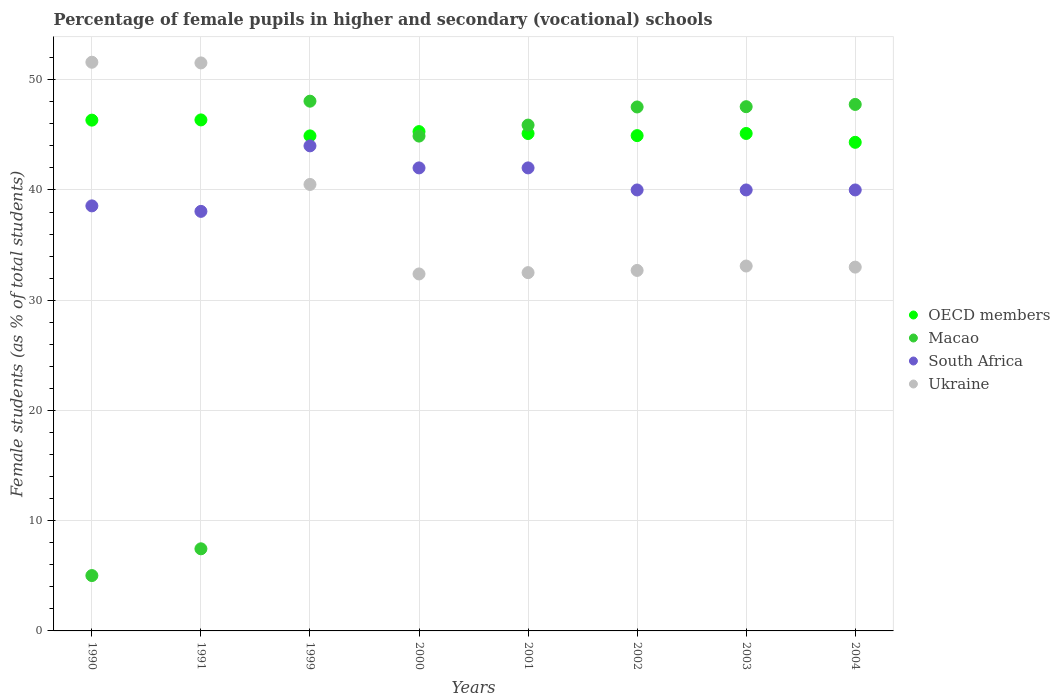How many different coloured dotlines are there?
Your answer should be very brief. 4. What is the percentage of female pupils in higher and secondary schools in Macao in 2003?
Your response must be concise. 47.55. Across all years, what is the maximum percentage of female pupils in higher and secondary schools in South Africa?
Offer a very short reply. 44. Across all years, what is the minimum percentage of female pupils in higher and secondary schools in OECD members?
Offer a very short reply. 44.32. What is the total percentage of female pupils in higher and secondary schools in Ukraine in the graph?
Provide a short and direct response. 307.29. What is the difference between the percentage of female pupils in higher and secondary schools in OECD members in 1999 and that in 2000?
Your answer should be compact. -0.39. What is the difference between the percentage of female pupils in higher and secondary schools in Macao in 2004 and the percentage of female pupils in higher and secondary schools in Ukraine in 2000?
Offer a terse response. 15.38. What is the average percentage of female pupils in higher and secondary schools in Ukraine per year?
Make the answer very short. 38.41. In the year 1991, what is the difference between the percentage of female pupils in higher and secondary schools in South Africa and percentage of female pupils in higher and secondary schools in OECD members?
Offer a terse response. -8.3. In how many years, is the percentage of female pupils in higher and secondary schools in Macao greater than 30 %?
Give a very brief answer. 6. What is the ratio of the percentage of female pupils in higher and secondary schools in South Africa in 1990 to that in 2003?
Ensure brevity in your answer.  0.96. Is the difference between the percentage of female pupils in higher and secondary schools in South Africa in 2002 and 2004 greater than the difference between the percentage of female pupils in higher and secondary schools in OECD members in 2002 and 2004?
Offer a terse response. No. What is the difference between the highest and the second highest percentage of female pupils in higher and secondary schools in OECD members?
Provide a short and direct response. 0.02. What is the difference between the highest and the lowest percentage of female pupils in higher and secondary schools in Macao?
Keep it short and to the point. 43.03. In how many years, is the percentage of female pupils in higher and secondary schools in Ukraine greater than the average percentage of female pupils in higher and secondary schools in Ukraine taken over all years?
Provide a short and direct response. 3. Is the sum of the percentage of female pupils in higher and secondary schools in South Africa in 1990 and 2000 greater than the maximum percentage of female pupils in higher and secondary schools in OECD members across all years?
Provide a succinct answer. Yes. Is it the case that in every year, the sum of the percentage of female pupils in higher and secondary schools in Macao and percentage of female pupils in higher and secondary schools in Ukraine  is greater than the percentage of female pupils in higher and secondary schools in OECD members?
Ensure brevity in your answer.  Yes. Does the percentage of female pupils in higher and secondary schools in South Africa monotonically increase over the years?
Offer a terse response. No. What is the difference between two consecutive major ticks on the Y-axis?
Offer a very short reply. 10. Are the values on the major ticks of Y-axis written in scientific E-notation?
Your response must be concise. No. What is the title of the graph?
Your response must be concise. Percentage of female pupils in higher and secondary (vocational) schools. Does "Poland" appear as one of the legend labels in the graph?
Ensure brevity in your answer.  No. What is the label or title of the X-axis?
Offer a very short reply. Years. What is the label or title of the Y-axis?
Keep it short and to the point. Female students (as % of total students). What is the Female students (as % of total students) in OECD members in 1990?
Provide a succinct answer. 46.33. What is the Female students (as % of total students) in Macao in 1990?
Provide a short and direct response. 5.02. What is the Female students (as % of total students) in South Africa in 1990?
Your answer should be compact. 38.56. What is the Female students (as % of total students) of Ukraine in 1990?
Your response must be concise. 51.58. What is the Female students (as % of total students) in OECD members in 1991?
Keep it short and to the point. 46.35. What is the Female students (as % of total students) of Macao in 1991?
Offer a terse response. 7.45. What is the Female students (as % of total students) in South Africa in 1991?
Offer a very short reply. 38.06. What is the Female students (as % of total students) in Ukraine in 1991?
Your response must be concise. 51.52. What is the Female students (as % of total students) in OECD members in 1999?
Provide a short and direct response. 44.9. What is the Female students (as % of total students) of Macao in 1999?
Provide a succinct answer. 48.05. What is the Female students (as % of total students) in South Africa in 1999?
Your answer should be very brief. 44. What is the Female students (as % of total students) of Ukraine in 1999?
Keep it short and to the point. 40.5. What is the Female students (as % of total students) of OECD members in 2000?
Your answer should be compact. 45.29. What is the Female students (as % of total students) in Macao in 2000?
Your answer should be compact. 44.89. What is the Female students (as % of total students) in South Africa in 2000?
Offer a terse response. 42. What is the Female students (as % of total students) in Ukraine in 2000?
Offer a very short reply. 32.38. What is the Female students (as % of total students) of OECD members in 2001?
Your answer should be very brief. 45.12. What is the Female students (as % of total students) in Macao in 2001?
Make the answer very short. 45.88. What is the Female students (as % of total students) in South Africa in 2001?
Give a very brief answer. 42. What is the Female students (as % of total students) in Ukraine in 2001?
Your answer should be very brief. 32.5. What is the Female students (as % of total students) of OECD members in 2002?
Your response must be concise. 44.93. What is the Female students (as % of total students) of Macao in 2002?
Your answer should be very brief. 47.53. What is the Female students (as % of total students) of South Africa in 2002?
Keep it short and to the point. 40. What is the Female students (as % of total students) of Ukraine in 2002?
Your response must be concise. 32.7. What is the Female students (as % of total students) of OECD members in 2003?
Offer a very short reply. 45.12. What is the Female students (as % of total students) in Macao in 2003?
Provide a short and direct response. 47.55. What is the Female students (as % of total students) in South Africa in 2003?
Offer a terse response. 40. What is the Female students (as % of total students) in Ukraine in 2003?
Make the answer very short. 33.1. What is the Female students (as % of total students) in OECD members in 2004?
Your answer should be very brief. 44.32. What is the Female students (as % of total students) in Macao in 2004?
Make the answer very short. 47.76. What is the Female students (as % of total students) in South Africa in 2004?
Your answer should be very brief. 40. What is the Female students (as % of total students) in Ukraine in 2004?
Keep it short and to the point. 33. Across all years, what is the maximum Female students (as % of total students) of OECD members?
Provide a succinct answer. 46.35. Across all years, what is the maximum Female students (as % of total students) in Macao?
Your answer should be compact. 48.05. Across all years, what is the maximum Female students (as % of total students) in South Africa?
Your answer should be very brief. 44. Across all years, what is the maximum Female students (as % of total students) of Ukraine?
Offer a very short reply. 51.58. Across all years, what is the minimum Female students (as % of total students) in OECD members?
Offer a terse response. 44.32. Across all years, what is the minimum Female students (as % of total students) of Macao?
Provide a succinct answer. 5.02. Across all years, what is the minimum Female students (as % of total students) in South Africa?
Your answer should be compact. 38.06. Across all years, what is the minimum Female students (as % of total students) in Ukraine?
Make the answer very short. 32.38. What is the total Female students (as % of total students) of OECD members in the graph?
Ensure brevity in your answer.  362.38. What is the total Female students (as % of total students) of Macao in the graph?
Offer a very short reply. 294.13. What is the total Female students (as % of total students) of South Africa in the graph?
Your answer should be compact. 324.61. What is the total Female students (as % of total students) in Ukraine in the graph?
Your answer should be very brief. 307.29. What is the difference between the Female students (as % of total students) in OECD members in 1990 and that in 1991?
Provide a succinct answer. -0.02. What is the difference between the Female students (as % of total students) in Macao in 1990 and that in 1991?
Give a very brief answer. -2.43. What is the difference between the Female students (as % of total students) of South Africa in 1990 and that in 1991?
Ensure brevity in your answer.  0.5. What is the difference between the Female students (as % of total students) in Ukraine in 1990 and that in 1991?
Offer a terse response. 0.06. What is the difference between the Female students (as % of total students) of OECD members in 1990 and that in 1999?
Offer a terse response. 1.43. What is the difference between the Female students (as % of total students) of Macao in 1990 and that in 1999?
Keep it short and to the point. -43.03. What is the difference between the Female students (as % of total students) in South Africa in 1990 and that in 1999?
Keep it short and to the point. -5.44. What is the difference between the Female students (as % of total students) in Ukraine in 1990 and that in 1999?
Make the answer very short. 11.08. What is the difference between the Female students (as % of total students) in OECD members in 1990 and that in 2000?
Ensure brevity in your answer.  1.04. What is the difference between the Female students (as % of total students) of Macao in 1990 and that in 2000?
Your answer should be compact. -39.86. What is the difference between the Female students (as % of total students) of South Africa in 1990 and that in 2000?
Give a very brief answer. -3.44. What is the difference between the Female students (as % of total students) of Ukraine in 1990 and that in 2000?
Your answer should be very brief. 19.2. What is the difference between the Female students (as % of total students) in OECD members in 1990 and that in 2001?
Provide a short and direct response. 1.21. What is the difference between the Female students (as % of total students) in Macao in 1990 and that in 2001?
Your answer should be compact. -40.86. What is the difference between the Female students (as % of total students) of South Africa in 1990 and that in 2001?
Keep it short and to the point. -3.44. What is the difference between the Female students (as % of total students) in Ukraine in 1990 and that in 2001?
Offer a terse response. 19.09. What is the difference between the Female students (as % of total students) in OECD members in 1990 and that in 2002?
Give a very brief answer. 1.4. What is the difference between the Female students (as % of total students) in Macao in 1990 and that in 2002?
Offer a terse response. -42.51. What is the difference between the Female students (as % of total students) of South Africa in 1990 and that in 2002?
Your answer should be compact. -1.44. What is the difference between the Female students (as % of total students) of Ukraine in 1990 and that in 2002?
Your answer should be very brief. 18.88. What is the difference between the Female students (as % of total students) of OECD members in 1990 and that in 2003?
Your answer should be compact. 1.21. What is the difference between the Female students (as % of total students) of Macao in 1990 and that in 2003?
Make the answer very short. -42.53. What is the difference between the Female students (as % of total students) in South Africa in 1990 and that in 2003?
Your response must be concise. -1.44. What is the difference between the Female students (as % of total students) of Ukraine in 1990 and that in 2003?
Make the answer very short. 18.48. What is the difference between the Female students (as % of total students) in OECD members in 1990 and that in 2004?
Your answer should be very brief. 2.01. What is the difference between the Female students (as % of total students) of Macao in 1990 and that in 2004?
Your response must be concise. -42.74. What is the difference between the Female students (as % of total students) in South Africa in 1990 and that in 2004?
Offer a very short reply. -1.44. What is the difference between the Female students (as % of total students) of Ukraine in 1990 and that in 2004?
Offer a very short reply. 18.58. What is the difference between the Female students (as % of total students) of OECD members in 1991 and that in 1999?
Offer a terse response. 1.45. What is the difference between the Female students (as % of total students) in Macao in 1991 and that in 1999?
Keep it short and to the point. -40.6. What is the difference between the Female students (as % of total students) of South Africa in 1991 and that in 1999?
Offer a very short reply. -5.94. What is the difference between the Female students (as % of total students) of Ukraine in 1991 and that in 1999?
Your answer should be compact. 11.02. What is the difference between the Female students (as % of total students) of OECD members in 1991 and that in 2000?
Provide a short and direct response. 1.06. What is the difference between the Female students (as % of total students) in Macao in 1991 and that in 2000?
Your answer should be compact. -37.44. What is the difference between the Female students (as % of total students) in South Africa in 1991 and that in 2000?
Provide a short and direct response. -3.94. What is the difference between the Female students (as % of total students) in Ukraine in 1991 and that in 2000?
Your answer should be compact. 19.14. What is the difference between the Female students (as % of total students) in OECD members in 1991 and that in 2001?
Offer a terse response. 1.23. What is the difference between the Female students (as % of total students) of Macao in 1991 and that in 2001?
Keep it short and to the point. -38.44. What is the difference between the Female students (as % of total students) in South Africa in 1991 and that in 2001?
Ensure brevity in your answer.  -3.94. What is the difference between the Female students (as % of total students) of Ukraine in 1991 and that in 2001?
Give a very brief answer. 19.02. What is the difference between the Female students (as % of total students) of OECD members in 1991 and that in 2002?
Your answer should be very brief. 1.43. What is the difference between the Female students (as % of total students) of Macao in 1991 and that in 2002?
Provide a short and direct response. -40.08. What is the difference between the Female students (as % of total students) of South Africa in 1991 and that in 2002?
Offer a very short reply. -1.94. What is the difference between the Female students (as % of total students) of Ukraine in 1991 and that in 2002?
Your response must be concise. 18.82. What is the difference between the Female students (as % of total students) of OECD members in 1991 and that in 2003?
Your answer should be compact. 1.23. What is the difference between the Female students (as % of total students) in Macao in 1991 and that in 2003?
Your answer should be very brief. -40.1. What is the difference between the Female students (as % of total students) in South Africa in 1991 and that in 2003?
Offer a very short reply. -1.94. What is the difference between the Female students (as % of total students) in Ukraine in 1991 and that in 2003?
Provide a short and direct response. 18.42. What is the difference between the Female students (as % of total students) of OECD members in 1991 and that in 2004?
Make the answer very short. 2.03. What is the difference between the Female students (as % of total students) of Macao in 1991 and that in 2004?
Give a very brief answer. -40.31. What is the difference between the Female students (as % of total students) in South Africa in 1991 and that in 2004?
Ensure brevity in your answer.  -1.94. What is the difference between the Female students (as % of total students) of Ukraine in 1991 and that in 2004?
Keep it short and to the point. 18.52. What is the difference between the Female students (as % of total students) of OECD members in 1999 and that in 2000?
Offer a very short reply. -0.39. What is the difference between the Female students (as % of total students) in Macao in 1999 and that in 2000?
Your answer should be very brief. 3.17. What is the difference between the Female students (as % of total students) in South Africa in 1999 and that in 2000?
Your answer should be very brief. 2. What is the difference between the Female students (as % of total students) in Ukraine in 1999 and that in 2000?
Your response must be concise. 8.12. What is the difference between the Female students (as % of total students) in OECD members in 1999 and that in 2001?
Offer a very short reply. -0.22. What is the difference between the Female students (as % of total students) in Macao in 1999 and that in 2001?
Give a very brief answer. 2.17. What is the difference between the Female students (as % of total students) of South Africa in 1999 and that in 2001?
Your answer should be compact. 2. What is the difference between the Female students (as % of total students) in Ukraine in 1999 and that in 2001?
Your answer should be compact. 8. What is the difference between the Female students (as % of total students) of OECD members in 1999 and that in 2002?
Make the answer very short. -0.03. What is the difference between the Female students (as % of total students) in Macao in 1999 and that in 2002?
Keep it short and to the point. 0.53. What is the difference between the Female students (as % of total students) in South Africa in 1999 and that in 2002?
Provide a short and direct response. 4. What is the difference between the Female students (as % of total students) of Ukraine in 1999 and that in 2002?
Keep it short and to the point. 7.8. What is the difference between the Female students (as % of total students) of OECD members in 1999 and that in 2003?
Your answer should be very brief. -0.22. What is the difference between the Female students (as % of total students) of Macao in 1999 and that in 2003?
Provide a short and direct response. 0.5. What is the difference between the Female students (as % of total students) of South Africa in 1999 and that in 2003?
Your answer should be very brief. 4. What is the difference between the Female students (as % of total students) of Ukraine in 1999 and that in 2003?
Offer a very short reply. 7.4. What is the difference between the Female students (as % of total students) of OECD members in 1999 and that in 2004?
Your answer should be compact. 0.58. What is the difference between the Female students (as % of total students) of Macao in 1999 and that in 2004?
Give a very brief answer. 0.3. What is the difference between the Female students (as % of total students) of South Africa in 1999 and that in 2004?
Offer a terse response. 4. What is the difference between the Female students (as % of total students) in Ukraine in 1999 and that in 2004?
Provide a short and direct response. 7.5. What is the difference between the Female students (as % of total students) in OECD members in 2000 and that in 2001?
Provide a succinct answer. 0.17. What is the difference between the Female students (as % of total students) of Macao in 2000 and that in 2001?
Your response must be concise. -1. What is the difference between the Female students (as % of total students) of South Africa in 2000 and that in 2001?
Give a very brief answer. 0. What is the difference between the Female students (as % of total students) in Ukraine in 2000 and that in 2001?
Your answer should be compact. -0.12. What is the difference between the Female students (as % of total students) of OECD members in 2000 and that in 2002?
Keep it short and to the point. 0.36. What is the difference between the Female students (as % of total students) in Macao in 2000 and that in 2002?
Keep it short and to the point. -2.64. What is the difference between the Female students (as % of total students) in South Africa in 2000 and that in 2002?
Give a very brief answer. 2. What is the difference between the Female students (as % of total students) of Ukraine in 2000 and that in 2002?
Provide a succinct answer. -0.32. What is the difference between the Female students (as % of total students) of OECD members in 2000 and that in 2003?
Your answer should be compact. 0.17. What is the difference between the Female students (as % of total students) of Macao in 2000 and that in 2003?
Provide a short and direct response. -2.67. What is the difference between the Female students (as % of total students) of Ukraine in 2000 and that in 2003?
Keep it short and to the point. -0.72. What is the difference between the Female students (as % of total students) of OECD members in 2000 and that in 2004?
Your answer should be very brief. 0.97. What is the difference between the Female students (as % of total students) in Macao in 2000 and that in 2004?
Ensure brevity in your answer.  -2.87. What is the difference between the Female students (as % of total students) in South Africa in 2000 and that in 2004?
Your answer should be compact. 2. What is the difference between the Female students (as % of total students) of Ukraine in 2000 and that in 2004?
Provide a succinct answer. -0.62. What is the difference between the Female students (as % of total students) of OECD members in 2001 and that in 2002?
Your answer should be very brief. 0.19. What is the difference between the Female students (as % of total students) of Macao in 2001 and that in 2002?
Keep it short and to the point. -1.64. What is the difference between the Female students (as % of total students) of South Africa in 2001 and that in 2002?
Your answer should be compact. 2. What is the difference between the Female students (as % of total students) of OECD members in 2001 and that in 2003?
Offer a terse response. -0. What is the difference between the Female students (as % of total students) in Macao in 2001 and that in 2003?
Provide a short and direct response. -1.67. What is the difference between the Female students (as % of total students) of OECD members in 2001 and that in 2004?
Provide a short and direct response. 0.8. What is the difference between the Female students (as % of total students) of Macao in 2001 and that in 2004?
Your answer should be compact. -1.87. What is the difference between the Female students (as % of total students) in Ukraine in 2001 and that in 2004?
Ensure brevity in your answer.  -0.5. What is the difference between the Female students (as % of total students) in OECD members in 2002 and that in 2003?
Offer a terse response. -0.2. What is the difference between the Female students (as % of total students) in Macao in 2002 and that in 2003?
Your answer should be compact. -0.03. What is the difference between the Female students (as % of total students) in South Africa in 2002 and that in 2003?
Your response must be concise. -0. What is the difference between the Female students (as % of total students) of Ukraine in 2002 and that in 2003?
Your answer should be compact. -0.4. What is the difference between the Female students (as % of total students) of OECD members in 2002 and that in 2004?
Your answer should be very brief. 0.61. What is the difference between the Female students (as % of total students) of Macao in 2002 and that in 2004?
Your answer should be very brief. -0.23. What is the difference between the Female students (as % of total students) of South Africa in 2002 and that in 2004?
Give a very brief answer. -0. What is the difference between the Female students (as % of total students) of Ukraine in 2002 and that in 2004?
Your answer should be compact. -0.3. What is the difference between the Female students (as % of total students) of OECD members in 2003 and that in 2004?
Ensure brevity in your answer.  0.8. What is the difference between the Female students (as % of total students) of Macao in 2003 and that in 2004?
Your response must be concise. -0.2. What is the difference between the Female students (as % of total students) in South Africa in 2003 and that in 2004?
Ensure brevity in your answer.  0. What is the difference between the Female students (as % of total students) of Ukraine in 2003 and that in 2004?
Offer a terse response. 0.1. What is the difference between the Female students (as % of total students) of OECD members in 1990 and the Female students (as % of total students) of Macao in 1991?
Your response must be concise. 38.89. What is the difference between the Female students (as % of total students) of OECD members in 1990 and the Female students (as % of total students) of South Africa in 1991?
Keep it short and to the point. 8.28. What is the difference between the Female students (as % of total students) in OECD members in 1990 and the Female students (as % of total students) in Ukraine in 1991?
Ensure brevity in your answer.  -5.19. What is the difference between the Female students (as % of total students) of Macao in 1990 and the Female students (as % of total students) of South Africa in 1991?
Give a very brief answer. -33.04. What is the difference between the Female students (as % of total students) of Macao in 1990 and the Female students (as % of total students) of Ukraine in 1991?
Offer a terse response. -46.5. What is the difference between the Female students (as % of total students) of South Africa in 1990 and the Female students (as % of total students) of Ukraine in 1991?
Your response must be concise. -12.97. What is the difference between the Female students (as % of total students) in OECD members in 1990 and the Female students (as % of total students) in Macao in 1999?
Offer a very short reply. -1.72. What is the difference between the Female students (as % of total students) of OECD members in 1990 and the Female students (as % of total students) of South Africa in 1999?
Your answer should be compact. 2.33. What is the difference between the Female students (as % of total students) of OECD members in 1990 and the Female students (as % of total students) of Ukraine in 1999?
Your answer should be compact. 5.83. What is the difference between the Female students (as % of total students) of Macao in 1990 and the Female students (as % of total students) of South Africa in 1999?
Your response must be concise. -38.98. What is the difference between the Female students (as % of total students) in Macao in 1990 and the Female students (as % of total students) in Ukraine in 1999?
Provide a succinct answer. -35.48. What is the difference between the Female students (as % of total students) of South Africa in 1990 and the Female students (as % of total students) of Ukraine in 1999?
Your answer should be compact. -1.94. What is the difference between the Female students (as % of total students) of OECD members in 1990 and the Female students (as % of total students) of Macao in 2000?
Ensure brevity in your answer.  1.45. What is the difference between the Female students (as % of total students) in OECD members in 1990 and the Female students (as % of total students) in South Africa in 2000?
Ensure brevity in your answer.  4.33. What is the difference between the Female students (as % of total students) of OECD members in 1990 and the Female students (as % of total students) of Ukraine in 2000?
Offer a very short reply. 13.95. What is the difference between the Female students (as % of total students) in Macao in 1990 and the Female students (as % of total students) in South Africa in 2000?
Make the answer very short. -36.98. What is the difference between the Female students (as % of total students) in Macao in 1990 and the Female students (as % of total students) in Ukraine in 2000?
Give a very brief answer. -27.36. What is the difference between the Female students (as % of total students) in South Africa in 1990 and the Female students (as % of total students) in Ukraine in 2000?
Provide a short and direct response. 6.17. What is the difference between the Female students (as % of total students) of OECD members in 1990 and the Female students (as % of total students) of Macao in 2001?
Offer a terse response. 0.45. What is the difference between the Female students (as % of total students) in OECD members in 1990 and the Female students (as % of total students) in South Africa in 2001?
Offer a terse response. 4.33. What is the difference between the Female students (as % of total students) in OECD members in 1990 and the Female students (as % of total students) in Ukraine in 2001?
Offer a terse response. 13.83. What is the difference between the Female students (as % of total students) of Macao in 1990 and the Female students (as % of total students) of South Africa in 2001?
Your answer should be compact. -36.98. What is the difference between the Female students (as % of total students) in Macao in 1990 and the Female students (as % of total students) in Ukraine in 2001?
Your response must be concise. -27.48. What is the difference between the Female students (as % of total students) of South Africa in 1990 and the Female students (as % of total students) of Ukraine in 2001?
Your response must be concise. 6.06. What is the difference between the Female students (as % of total students) in OECD members in 1990 and the Female students (as % of total students) in Macao in 2002?
Ensure brevity in your answer.  -1.19. What is the difference between the Female students (as % of total students) of OECD members in 1990 and the Female students (as % of total students) of South Africa in 2002?
Provide a short and direct response. 6.33. What is the difference between the Female students (as % of total students) in OECD members in 1990 and the Female students (as % of total students) in Ukraine in 2002?
Make the answer very short. 13.63. What is the difference between the Female students (as % of total students) of Macao in 1990 and the Female students (as % of total students) of South Africa in 2002?
Your response must be concise. -34.98. What is the difference between the Female students (as % of total students) of Macao in 1990 and the Female students (as % of total students) of Ukraine in 2002?
Keep it short and to the point. -27.68. What is the difference between the Female students (as % of total students) of South Africa in 1990 and the Female students (as % of total students) of Ukraine in 2002?
Offer a terse response. 5.86. What is the difference between the Female students (as % of total students) in OECD members in 1990 and the Female students (as % of total students) in Macao in 2003?
Keep it short and to the point. -1.22. What is the difference between the Female students (as % of total students) of OECD members in 1990 and the Female students (as % of total students) of South Africa in 2003?
Keep it short and to the point. 6.33. What is the difference between the Female students (as % of total students) in OECD members in 1990 and the Female students (as % of total students) in Ukraine in 2003?
Your answer should be very brief. 13.23. What is the difference between the Female students (as % of total students) of Macao in 1990 and the Female students (as % of total students) of South Africa in 2003?
Your answer should be very brief. -34.98. What is the difference between the Female students (as % of total students) in Macao in 1990 and the Female students (as % of total students) in Ukraine in 2003?
Provide a succinct answer. -28.08. What is the difference between the Female students (as % of total students) of South Africa in 1990 and the Female students (as % of total students) of Ukraine in 2003?
Offer a very short reply. 5.46. What is the difference between the Female students (as % of total students) of OECD members in 1990 and the Female students (as % of total students) of Macao in 2004?
Offer a terse response. -1.42. What is the difference between the Female students (as % of total students) in OECD members in 1990 and the Female students (as % of total students) in South Africa in 2004?
Keep it short and to the point. 6.33. What is the difference between the Female students (as % of total students) in OECD members in 1990 and the Female students (as % of total students) in Ukraine in 2004?
Ensure brevity in your answer.  13.33. What is the difference between the Female students (as % of total students) in Macao in 1990 and the Female students (as % of total students) in South Africa in 2004?
Offer a very short reply. -34.98. What is the difference between the Female students (as % of total students) in Macao in 1990 and the Female students (as % of total students) in Ukraine in 2004?
Make the answer very short. -27.98. What is the difference between the Female students (as % of total students) in South Africa in 1990 and the Female students (as % of total students) in Ukraine in 2004?
Your response must be concise. 5.56. What is the difference between the Female students (as % of total students) in OECD members in 1991 and the Female students (as % of total students) in Macao in 1999?
Your answer should be compact. -1.7. What is the difference between the Female students (as % of total students) in OECD members in 1991 and the Female students (as % of total students) in South Africa in 1999?
Make the answer very short. 2.35. What is the difference between the Female students (as % of total students) of OECD members in 1991 and the Female students (as % of total students) of Ukraine in 1999?
Keep it short and to the point. 5.85. What is the difference between the Female students (as % of total students) of Macao in 1991 and the Female students (as % of total students) of South Africa in 1999?
Ensure brevity in your answer.  -36.55. What is the difference between the Female students (as % of total students) of Macao in 1991 and the Female students (as % of total students) of Ukraine in 1999?
Keep it short and to the point. -33.05. What is the difference between the Female students (as % of total students) in South Africa in 1991 and the Female students (as % of total students) in Ukraine in 1999?
Offer a very short reply. -2.44. What is the difference between the Female students (as % of total students) in OECD members in 1991 and the Female students (as % of total students) in Macao in 2000?
Give a very brief answer. 1.47. What is the difference between the Female students (as % of total students) in OECD members in 1991 and the Female students (as % of total students) in South Africa in 2000?
Your response must be concise. 4.35. What is the difference between the Female students (as % of total students) in OECD members in 1991 and the Female students (as % of total students) in Ukraine in 2000?
Ensure brevity in your answer.  13.97. What is the difference between the Female students (as % of total students) of Macao in 1991 and the Female students (as % of total students) of South Africa in 2000?
Offer a terse response. -34.55. What is the difference between the Female students (as % of total students) in Macao in 1991 and the Female students (as % of total students) in Ukraine in 2000?
Offer a very short reply. -24.93. What is the difference between the Female students (as % of total students) of South Africa in 1991 and the Female students (as % of total students) of Ukraine in 2000?
Provide a short and direct response. 5.68. What is the difference between the Female students (as % of total students) of OECD members in 1991 and the Female students (as % of total students) of Macao in 2001?
Make the answer very short. 0.47. What is the difference between the Female students (as % of total students) of OECD members in 1991 and the Female students (as % of total students) of South Africa in 2001?
Provide a short and direct response. 4.35. What is the difference between the Female students (as % of total students) of OECD members in 1991 and the Female students (as % of total students) of Ukraine in 2001?
Your answer should be very brief. 13.85. What is the difference between the Female students (as % of total students) in Macao in 1991 and the Female students (as % of total students) in South Africa in 2001?
Ensure brevity in your answer.  -34.55. What is the difference between the Female students (as % of total students) of Macao in 1991 and the Female students (as % of total students) of Ukraine in 2001?
Ensure brevity in your answer.  -25.05. What is the difference between the Female students (as % of total students) of South Africa in 1991 and the Female students (as % of total students) of Ukraine in 2001?
Your answer should be compact. 5.56. What is the difference between the Female students (as % of total students) in OECD members in 1991 and the Female students (as % of total students) in Macao in 2002?
Make the answer very short. -1.17. What is the difference between the Female students (as % of total students) of OECD members in 1991 and the Female students (as % of total students) of South Africa in 2002?
Provide a short and direct response. 6.35. What is the difference between the Female students (as % of total students) of OECD members in 1991 and the Female students (as % of total students) of Ukraine in 2002?
Make the answer very short. 13.65. What is the difference between the Female students (as % of total students) of Macao in 1991 and the Female students (as % of total students) of South Africa in 2002?
Your response must be concise. -32.55. What is the difference between the Female students (as % of total students) of Macao in 1991 and the Female students (as % of total students) of Ukraine in 2002?
Provide a short and direct response. -25.25. What is the difference between the Female students (as % of total students) of South Africa in 1991 and the Female students (as % of total students) of Ukraine in 2002?
Provide a succinct answer. 5.36. What is the difference between the Female students (as % of total students) of OECD members in 1991 and the Female students (as % of total students) of Macao in 2003?
Make the answer very short. -1.2. What is the difference between the Female students (as % of total students) of OECD members in 1991 and the Female students (as % of total students) of South Africa in 2003?
Your answer should be compact. 6.35. What is the difference between the Female students (as % of total students) in OECD members in 1991 and the Female students (as % of total students) in Ukraine in 2003?
Ensure brevity in your answer.  13.25. What is the difference between the Female students (as % of total students) in Macao in 1991 and the Female students (as % of total students) in South Africa in 2003?
Your answer should be compact. -32.55. What is the difference between the Female students (as % of total students) in Macao in 1991 and the Female students (as % of total students) in Ukraine in 2003?
Your answer should be very brief. -25.65. What is the difference between the Female students (as % of total students) of South Africa in 1991 and the Female students (as % of total students) of Ukraine in 2003?
Give a very brief answer. 4.96. What is the difference between the Female students (as % of total students) in OECD members in 1991 and the Female students (as % of total students) in Macao in 2004?
Give a very brief answer. -1.4. What is the difference between the Female students (as % of total students) in OECD members in 1991 and the Female students (as % of total students) in South Africa in 2004?
Offer a very short reply. 6.35. What is the difference between the Female students (as % of total students) in OECD members in 1991 and the Female students (as % of total students) in Ukraine in 2004?
Your answer should be compact. 13.35. What is the difference between the Female students (as % of total students) of Macao in 1991 and the Female students (as % of total students) of South Africa in 2004?
Your response must be concise. -32.55. What is the difference between the Female students (as % of total students) of Macao in 1991 and the Female students (as % of total students) of Ukraine in 2004?
Give a very brief answer. -25.55. What is the difference between the Female students (as % of total students) in South Africa in 1991 and the Female students (as % of total students) in Ukraine in 2004?
Make the answer very short. 5.06. What is the difference between the Female students (as % of total students) in OECD members in 1999 and the Female students (as % of total students) in Macao in 2000?
Give a very brief answer. 0.02. What is the difference between the Female students (as % of total students) of OECD members in 1999 and the Female students (as % of total students) of South Africa in 2000?
Your answer should be compact. 2.9. What is the difference between the Female students (as % of total students) in OECD members in 1999 and the Female students (as % of total students) in Ukraine in 2000?
Ensure brevity in your answer.  12.52. What is the difference between the Female students (as % of total students) in Macao in 1999 and the Female students (as % of total students) in South Africa in 2000?
Offer a terse response. 6.05. What is the difference between the Female students (as % of total students) of Macao in 1999 and the Female students (as % of total students) of Ukraine in 2000?
Make the answer very short. 15.67. What is the difference between the Female students (as % of total students) of South Africa in 1999 and the Female students (as % of total students) of Ukraine in 2000?
Offer a terse response. 11.62. What is the difference between the Female students (as % of total students) in OECD members in 1999 and the Female students (as % of total students) in Macao in 2001?
Provide a short and direct response. -0.98. What is the difference between the Female students (as % of total students) of OECD members in 1999 and the Female students (as % of total students) of South Africa in 2001?
Your response must be concise. 2.9. What is the difference between the Female students (as % of total students) of OECD members in 1999 and the Female students (as % of total students) of Ukraine in 2001?
Your answer should be very brief. 12.4. What is the difference between the Female students (as % of total students) in Macao in 1999 and the Female students (as % of total students) in South Africa in 2001?
Your response must be concise. 6.05. What is the difference between the Female students (as % of total students) in Macao in 1999 and the Female students (as % of total students) in Ukraine in 2001?
Your answer should be compact. 15.55. What is the difference between the Female students (as % of total students) of South Africa in 1999 and the Female students (as % of total students) of Ukraine in 2001?
Give a very brief answer. 11.5. What is the difference between the Female students (as % of total students) in OECD members in 1999 and the Female students (as % of total students) in Macao in 2002?
Provide a short and direct response. -2.62. What is the difference between the Female students (as % of total students) in OECD members in 1999 and the Female students (as % of total students) in South Africa in 2002?
Offer a very short reply. 4.9. What is the difference between the Female students (as % of total students) of OECD members in 1999 and the Female students (as % of total students) of Ukraine in 2002?
Make the answer very short. 12.2. What is the difference between the Female students (as % of total students) in Macao in 1999 and the Female students (as % of total students) in South Africa in 2002?
Your response must be concise. 8.05. What is the difference between the Female students (as % of total students) of Macao in 1999 and the Female students (as % of total students) of Ukraine in 2002?
Offer a very short reply. 15.35. What is the difference between the Female students (as % of total students) of South Africa in 1999 and the Female students (as % of total students) of Ukraine in 2002?
Your answer should be compact. 11.3. What is the difference between the Female students (as % of total students) in OECD members in 1999 and the Female students (as % of total students) in Macao in 2003?
Your answer should be very brief. -2.65. What is the difference between the Female students (as % of total students) of OECD members in 1999 and the Female students (as % of total students) of South Africa in 2003?
Keep it short and to the point. 4.9. What is the difference between the Female students (as % of total students) of OECD members in 1999 and the Female students (as % of total students) of Ukraine in 2003?
Your answer should be very brief. 11.8. What is the difference between the Female students (as % of total students) of Macao in 1999 and the Female students (as % of total students) of South Africa in 2003?
Offer a terse response. 8.05. What is the difference between the Female students (as % of total students) of Macao in 1999 and the Female students (as % of total students) of Ukraine in 2003?
Give a very brief answer. 14.95. What is the difference between the Female students (as % of total students) of South Africa in 1999 and the Female students (as % of total students) of Ukraine in 2003?
Make the answer very short. 10.9. What is the difference between the Female students (as % of total students) in OECD members in 1999 and the Female students (as % of total students) in Macao in 2004?
Your response must be concise. -2.85. What is the difference between the Female students (as % of total students) of OECD members in 1999 and the Female students (as % of total students) of South Africa in 2004?
Your answer should be very brief. 4.9. What is the difference between the Female students (as % of total students) of OECD members in 1999 and the Female students (as % of total students) of Ukraine in 2004?
Make the answer very short. 11.9. What is the difference between the Female students (as % of total students) of Macao in 1999 and the Female students (as % of total students) of South Africa in 2004?
Your answer should be very brief. 8.05. What is the difference between the Female students (as % of total students) of Macao in 1999 and the Female students (as % of total students) of Ukraine in 2004?
Your response must be concise. 15.05. What is the difference between the Female students (as % of total students) of South Africa in 1999 and the Female students (as % of total students) of Ukraine in 2004?
Your answer should be compact. 11. What is the difference between the Female students (as % of total students) of OECD members in 2000 and the Female students (as % of total students) of Macao in 2001?
Make the answer very short. -0.59. What is the difference between the Female students (as % of total students) in OECD members in 2000 and the Female students (as % of total students) in South Africa in 2001?
Make the answer very short. 3.29. What is the difference between the Female students (as % of total students) of OECD members in 2000 and the Female students (as % of total students) of Ukraine in 2001?
Provide a succinct answer. 12.79. What is the difference between the Female students (as % of total students) in Macao in 2000 and the Female students (as % of total students) in South Africa in 2001?
Offer a very short reply. 2.89. What is the difference between the Female students (as % of total students) of Macao in 2000 and the Female students (as % of total students) of Ukraine in 2001?
Your response must be concise. 12.39. What is the difference between the Female students (as % of total students) in South Africa in 2000 and the Female students (as % of total students) in Ukraine in 2001?
Offer a terse response. 9.5. What is the difference between the Female students (as % of total students) in OECD members in 2000 and the Female students (as % of total students) in Macao in 2002?
Ensure brevity in your answer.  -2.23. What is the difference between the Female students (as % of total students) in OECD members in 2000 and the Female students (as % of total students) in South Africa in 2002?
Offer a terse response. 5.29. What is the difference between the Female students (as % of total students) of OECD members in 2000 and the Female students (as % of total students) of Ukraine in 2002?
Ensure brevity in your answer.  12.59. What is the difference between the Female students (as % of total students) of Macao in 2000 and the Female students (as % of total students) of South Africa in 2002?
Provide a succinct answer. 4.89. What is the difference between the Female students (as % of total students) of Macao in 2000 and the Female students (as % of total students) of Ukraine in 2002?
Keep it short and to the point. 12.19. What is the difference between the Female students (as % of total students) of South Africa in 2000 and the Female students (as % of total students) of Ukraine in 2002?
Keep it short and to the point. 9.3. What is the difference between the Female students (as % of total students) of OECD members in 2000 and the Female students (as % of total students) of Macao in 2003?
Offer a terse response. -2.26. What is the difference between the Female students (as % of total students) in OECD members in 2000 and the Female students (as % of total students) in South Africa in 2003?
Offer a terse response. 5.29. What is the difference between the Female students (as % of total students) in OECD members in 2000 and the Female students (as % of total students) in Ukraine in 2003?
Give a very brief answer. 12.19. What is the difference between the Female students (as % of total students) in Macao in 2000 and the Female students (as % of total students) in South Africa in 2003?
Your answer should be compact. 4.89. What is the difference between the Female students (as % of total students) in Macao in 2000 and the Female students (as % of total students) in Ukraine in 2003?
Provide a succinct answer. 11.79. What is the difference between the Female students (as % of total students) of South Africa in 2000 and the Female students (as % of total students) of Ukraine in 2003?
Offer a terse response. 8.9. What is the difference between the Female students (as % of total students) in OECD members in 2000 and the Female students (as % of total students) in Macao in 2004?
Provide a succinct answer. -2.46. What is the difference between the Female students (as % of total students) of OECD members in 2000 and the Female students (as % of total students) of South Africa in 2004?
Make the answer very short. 5.29. What is the difference between the Female students (as % of total students) in OECD members in 2000 and the Female students (as % of total students) in Ukraine in 2004?
Keep it short and to the point. 12.29. What is the difference between the Female students (as % of total students) in Macao in 2000 and the Female students (as % of total students) in South Africa in 2004?
Ensure brevity in your answer.  4.89. What is the difference between the Female students (as % of total students) in Macao in 2000 and the Female students (as % of total students) in Ukraine in 2004?
Offer a very short reply. 11.89. What is the difference between the Female students (as % of total students) of South Africa in 2000 and the Female students (as % of total students) of Ukraine in 2004?
Your response must be concise. 9. What is the difference between the Female students (as % of total students) in OECD members in 2001 and the Female students (as % of total students) in Macao in 2002?
Your answer should be compact. -2.41. What is the difference between the Female students (as % of total students) of OECD members in 2001 and the Female students (as % of total students) of South Africa in 2002?
Your response must be concise. 5.12. What is the difference between the Female students (as % of total students) of OECD members in 2001 and the Female students (as % of total students) of Ukraine in 2002?
Offer a terse response. 12.42. What is the difference between the Female students (as % of total students) in Macao in 2001 and the Female students (as % of total students) in South Africa in 2002?
Offer a very short reply. 5.88. What is the difference between the Female students (as % of total students) of Macao in 2001 and the Female students (as % of total students) of Ukraine in 2002?
Ensure brevity in your answer.  13.18. What is the difference between the Female students (as % of total students) of South Africa in 2001 and the Female students (as % of total students) of Ukraine in 2002?
Offer a terse response. 9.3. What is the difference between the Female students (as % of total students) of OECD members in 2001 and the Female students (as % of total students) of Macao in 2003?
Keep it short and to the point. -2.43. What is the difference between the Female students (as % of total students) of OECD members in 2001 and the Female students (as % of total students) of South Africa in 2003?
Provide a succinct answer. 5.12. What is the difference between the Female students (as % of total students) in OECD members in 2001 and the Female students (as % of total students) in Ukraine in 2003?
Offer a terse response. 12.02. What is the difference between the Female students (as % of total students) in Macao in 2001 and the Female students (as % of total students) in South Africa in 2003?
Your answer should be very brief. 5.88. What is the difference between the Female students (as % of total students) of Macao in 2001 and the Female students (as % of total students) of Ukraine in 2003?
Give a very brief answer. 12.78. What is the difference between the Female students (as % of total students) of South Africa in 2001 and the Female students (as % of total students) of Ukraine in 2003?
Your response must be concise. 8.9. What is the difference between the Female students (as % of total students) in OECD members in 2001 and the Female students (as % of total students) in Macao in 2004?
Give a very brief answer. -2.64. What is the difference between the Female students (as % of total students) in OECD members in 2001 and the Female students (as % of total students) in South Africa in 2004?
Offer a very short reply. 5.12. What is the difference between the Female students (as % of total students) of OECD members in 2001 and the Female students (as % of total students) of Ukraine in 2004?
Give a very brief answer. 12.12. What is the difference between the Female students (as % of total students) in Macao in 2001 and the Female students (as % of total students) in South Africa in 2004?
Offer a terse response. 5.88. What is the difference between the Female students (as % of total students) in Macao in 2001 and the Female students (as % of total students) in Ukraine in 2004?
Offer a very short reply. 12.88. What is the difference between the Female students (as % of total students) of South Africa in 2001 and the Female students (as % of total students) of Ukraine in 2004?
Provide a succinct answer. 9. What is the difference between the Female students (as % of total students) in OECD members in 2002 and the Female students (as % of total students) in Macao in 2003?
Keep it short and to the point. -2.62. What is the difference between the Female students (as % of total students) in OECD members in 2002 and the Female students (as % of total students) in South Africa in 2003?
Offer a terse response. 4.93. What is the difference between the Female students (as % of total students) in OECD members in 2002 and the Female students (as % of total students) in Ukraine in 2003?
Offer a terse response. 11.83. What is the difference between the Female students (as % of total students) in Macao in 2002 and the Female students (as % of total students) in South Africa in 2003?
Provide a succinct answer. 7.53. What is the difference between the Female students (as % of total students) of Macao in 2002 and the Female students (as % of total students) of Ukraine in 2003?
Offer a terse response. 14.43. What is the difference between the Female students (as % of total students) of South Africa in 2002 and the Female students (as % of total students) of Ukraine in 2003?
Ensure brevity in your answer.  6.9. What is the difference between the Female students (as % of total students) of OECD members in 2002 and the Female students (as % of total students) of Macao in 2004?
Provide a succinct answer. -2.83. What is the difference between the Female students (as % of total students) in OECD members in 2002 and the Female students (as % of total students) in South Africa in 2004?
Ensure brevity in your answer.  4.93. What is the difference between the Female students (as % of total students) in OECD members in 2002 and the Female students (as % of total students) in Ukraine in 2004?
Your response must be concise. 11.93. What is the difference between the Female students (as % of total students) in Macao in 2002 and the Female students (as % of total students) in South Africa in 2004?
Your answer should be compact. 7.53. What is the difference between the Female students (as % of total students) in Macao in 2002 and the Female students (as % of total students) in Ukraine in 2004?
Provide a succinct answer. 14.53. What is the difference between the Female students (as % of total students) of South Africa in 2002 and the Female students (as % of total students) of Ukraine in 2004?
Offer a terse response. 7. What is the difference between the Female students (as % of total students) in OECD members in 2003 and the Female students (as % of total students) in Macao in 2004?
Your answer should be compact. -2.63. What is the difference between the Female students (as % of total students) in OECD members in 2003 and the Female students (as % of total students) in South Africa in 2004?
Ensure brevity in your answer.  5.12. What is the difference between the Female students (as % of total students) in OECD members in 2003 and the Female students (as % of total students) in Ukraine in 2004?
Give a very brief answer. 12.12. What is the difference between the Female students (as % of total students) in Macao in 2003 and the Female students (as % of total students) in South Africa in 2004?
Your answer should be very brief. 7.55. What is the difference between the Female students (as % of total students) of Macao in 2003 and the Female students (as % of total students) of Ukraine in 2004?
Ensure brevity in your answer.  14.55. What is the difference between the Female students (as % of total students) of South Africa in 2003 and the Female students (as % of total students) of Ukraine in 2004?
Keep it short and to the point. 7. What is the average Female students (as % of total students) in OECD members per year?
Provide a succinct answer. 45.3. What is the average Female students (as % of total students) of Macao per year?
Provide a short and direct response. 36.77. What is the average Female students (as % of total students) in South Africa per year?
Your answer should be compact. 40.58. What is the average Female students (as % of total students) of Ukraine per year?
Keep it short and to the point. 38.41. In the year 1990, what is the difference between the Female students (as % of total students) in OECD members and Female students (as % of total students) in Macao?
Ensure brevity in your answer.  41.31. In the year 1990, what is the difference between the Female students (as % of total students) of OECD members and Female students (as % of total students) of South Africa?
Your answer should be very brief. 7.78. In the year 1990, what is the difference between the Female students (as % of total students) of OECD members and Female students (as % of total students) of Ukraine?
Offer a very short reply. -5.25. In the year 1990, what is the difference between the Female students (as % of total students) in Macao and Female students (as % of total students) in South Africa?
Keep it short and to the point. -33.53. In the year 1990, what is the difference between the Female students (as % of total students) in Macao and Female students (as % of total students) in Ukraine?
Keep it short and to the point. -46.56. In the year 1990, what is the difference between the Female students (as % of total students) in South Africa and Female students (as % of total students) in Ukraine?
Keep it short and to the point. -13.03. In the year 1991, what is the difference between the Female students (as % of total students) in OECD members and Female students (as % of total students) in Macao?
Your answer should be compact. 38.91. In the year 1991, what is the difference between the Female students (as % of total students) of OECD members and Female students (as % of total students) of South Africa?
Provide a succinct answer. 8.3. In the year 1991, what is the difference between the Female students (as % of total students) in OECD members and Female students (as % of total students) in Ukraine?
Offer a terse response. -5.17. In the year 1991, what is the difference between the Female students (as % of total students) in Macao and Female students (as % of total students) in South Africa?
Your response must be concise. -30.61. In the year 1991, what is the difference between the Female students (as % of total students) in Macao and Female students (as % of total students) in Ukraine?
Ensure brevity in your answer.  -44.07. In the year 1991, what is the difference between the Female students (as % of total students) in South Africa and Female students (as % of total students) in Ukraine?
Provide a succinct answer. -13.47. In the year 1999, what is the difference between the Female students (as % of total students) in OECD members and Female students (as % of total students) in Macao?
Give a very brief answer. -3.15. In the year 1999, what is the difference between the Female students (as % of total students) of OECD members and Female students (as % of total students) of South Africa?
Your answer should be compact. 0.9. In the year 1999, what is the difference between the Female students (as % of total students) of OECD members and Female students (as % of total students) of Ukraine?
Make the answer very short. 4.4. In the year 1999, what is the difference between the Female students (as % of total students) in Macao and Female students (as % of total students) in South Africa?
Offer a terse response. 4.05. In the year 1999, what is the difference between the Female students (as % of total students) of Macao and Female students (as % of total students) of Ukraine?
Your answer should be very brief. 7.55. In the year 1999, what is the difference between the Female students (as % of total students) in South Africa and Female students (as % of total students) in Ukraine?
Keep it short and to the point. 3.5. In the year 2000, what is the difference between the Female students (as % of total students) of OECD members and Female students (as % of total students) of Macao?
Give a very brief answer. 0.41. In the year 2000, what is the difference between the Female students (as % of total students) of OECD members and Female students (as % of total students) of South Africa?
Offer a terse response. 3.29. In the year 2000, what is the difference between the Female students (as % of total students) of OECD members and Female students (as % of total students) of Ukraine?
Provide a succinct answer. 12.91. In the year 2000, what is the difference between the Female students (as % of total students) in Macao and Female students (as % of total students) in South Africa?
Ensure brevity in your answer.  2.89. In the year 2000, what is the difference between the Female students (as % of total students) in Macao and Female students (as % of total students) in Ukraine?
Your answer should be compact. 12.51. In the year 2000, what is the difference between the Female students (as % of total students) in South Africa and Female students (as % of total students) in Ukraine?
Keep it short and to the point. 9.62. In the year 2001, what is the difference between the Female students (as % of total students) in OECD members and Female students (as % of total students) in Macao?
Provide a short and direct response. -0.76. In the year 2001, what is the difference between the Female students (as % of total students) of OECD members and Female students (as % of total students) of South Africa?
Your response must be concise. 3.12. In the year 2001, what is the difference between the Female students (as % of total students) in OECD members and Female students (as % of total students) in Ukraine?
Offer a very short reply. 12.62. In the year 2001, what is the difference between the Female students (as % of total students) of Macao and Female students (as % of total students) of South Africa?
Provide a short and direct response. 3.88. In the year 2001, what is the difference between the Female students (as % of total students) of Macao and Female students (as % of total students) of Ukraine?
Ensure brevity in your answer.  13.38. In the year 2001, what is the difference between the Female students (as % of total students) in South Africa and Female students (as % of total students) in Ukraine?
Offer a very short reply. 9.5. In the year 2002, what is the difference between the Female students (as % of total students) of OECD members and Female students (as % of total students) of Macao?
Provide a succinct answer. -2.6. In the year 2002, what is the difference between the Female students (as % of total students) in OECD members and Female students (as % of total students) in South Africa?
Offer a terse response. 4.93. In the year 2002, what is the difference between the Female students (as % of total students) of OECD members and Female students (as % of total students) of Ukraine?
Make the answer very short. 12.23. In the year 2002, what is the difference between the Female students (as % of total students) in Macao and Female students (as % of total students) in South Africa?
Provide a short and direct response. 7.53. In the year 2002, what is the difference between the Female students (as % of total students) in Macao and Female students (as % of total students) in Ukraine?
Make the answer very short. 14.83. In the year 2003, what is the difference between the Female students (as % of total students) of OECD members and Female students (as % of total students) of Macao?
Make the answer very short. -2.43. In the year 2003, what is the difference between the Female students (as % of total students) of OECD members and Female students (as % of total students) of South Africa?
Provide a short and direct response. 5.12. In the year 2003, what is the difference between the Female students (as % of total students) of OECD members and Female students (as % of total students) of Ukraine?
Offer a terse response. 12.02. In the year 2003, what is the difference between the Female students (as % of total students) of Macao and Female students (as % of total students) of South Africa?
Your answer should be compact. 7.55. In the year 2003, what is the difference between the Female students (as % of total students) in Macao and Female students (as % of total students) in Ukraine?
Make the answer very short. 14.45. In the year 2003, what is the difference between the Female students (as % of total students) of South Africa and Female students (as % of total students) of Ukraine?
Your answer should be very brief. 6.9. In the year 2004, what is the difference between the Female students (as % of total students) of OECD members and Female students (as % of total students) of Macao?
Offer a very short reply. -3.44. In the year 2004, what is the difference between the Female students (as % of total students) in OECD members and Female students (as % of total students) in South Africa?
Offer a very short reply. 4.32. In the year 2004, what is the difference between the Female students (as % of total students) in OECD members and Female students (as % of total students) in Ukraine?
Provide a short and direct response. 11.32. In the year 2004, what is the difference between the Female students (as % of total students) in Macao and Female students (as % of total students) in South Africa?
Provide a short and direct response. 7.76. In the year 2004, what is the difference between the Female students (as % of total students) of Macao and Female students (as % of total students) of Ukraine?
Give a very brief answer. 14.76. In the year 2004, what is the difference between the Female students (as % of total students) of South Africa and Female students (as % of total students) of Ukraine?
Keep it short and to the point. 7. What is the ratio of the Female students (as % of total students) in OECD members in 1990 to that in 1991?
Offer a terse response. 1. What is the ratio of the Female students (as % of total students) in Macao in 1990 to that in 1991?
Ensure brevity in your answer.  0.67. What is the ratio of the Female students (as % of total students) in South Africa in 1990 to that in 1991?
Give a very brief answer. 1.01. What is the ratio of the Female students (as % of total students) in OECD members in 1990 to that in 1999?
Your answer should be very brief. 1.03. What is the ratio of the Female students (as % of total students) of Macao in 1990 to that in 1999?
Your response must be concise. 0.1. What is the ratio of the Female students (as % of total students) in South Africa in 1990 to that in 1999?
Your answer should be compact. 0.88. What is the ratio of the Female students (as % of total students) in Ukraine in 1990 to that in 1999?
Provide a succinct answer. 1.27. What is the ratio of the Female students (as % of total students) of Macao in 1990 to that in 2000?
Your response must be concise. 0.11. What is the ratio of the Female students (as % of total students) in South Africa in 1990 to that in 2000?
Make the answer very short. 0.92. What is the ratio of the Female students (as % of total students) in Ukraine in 1990 to that in 2000?
Your response must be concise. 1.59. What is the ratio of the Female students (as % of total students) in OECD members in 1990 to that in 2001?
Your answer should be compact. 1.03. What is the ratio of the Female students (as % of total students) in Macao in 1990 to that in 2001?
Ensure brevity in your answer.  0.11. What is the ratio of the Female students (as % of total students) of South Africa in 1990 to that in 2001?
Keep it short and to the point. 0.92. What is the ratio of the Female students (as % of total students) in Ukraine in 1990 to that in 2001?
Provide a succinct answer. 1.59. What is the ratio of the Female students (as % of total students) of OECD members in 1990 to that in 2002?
Your answer should be compact. 1.03. What is the ratio of the Female students (as % of total students) in Macao in 1990 to that in 2002?
Make the answer very short. 0.11. What is the ratio of the Female students (as % of total students) of South Africa in 1990 to that in 2002?
Give a very brief answer. 0.96. What is the ratio of the Female students (as % of total students) in Ukraine in 1990 to that in 2002?
Make the answer very short. 1.58. What is the ratio of the Female students (as % of total students) of OECD members in 1990 to that in 2003?
Offer a terse response. 1.03. What is the ratio of the Female students (as % of total students) of Macao in 1990 to that in 2003?
Offer a terse response. 0.11. What is the ratio of the Female students (as % of total students) in South Africa in 1990 to that in 2003?
Provide a short and direct response. 0.96. What is the ratio of the Female students (as % of total students) of Ukraine in 1990 to that in 2003?
Ensure brevity in your answer.  1.56. What is the ratio of the Female students (as % of total students) in OECD members in 1990 to that in 2004?
Offer a terse response. 1.05. What is the ratio of the Female students (as % of total students) of Macao in 1990 to that in 2004?
Offer a very short reply. 0.11. What is the ratio of the Female students (as % of total students) of South Africa in 1990 to that in 2004?
Give a very brief answer. 0.96. What is the ratio of the Female students (as % of total students) in Ukraine in 1990 to that in 2004?
Provide a succinct answer. 1.56. What is the ratio of the Female students (as % of total students) in OECD members in 1991 to that in 1999?
Offer a terse response. 1.03. What is the ratio of the Female students (as % of total students) in Macao in 1991 to that in 1999?
Give a very brief answer. 0.15. What is the ratio of the Female students (as % of total students) of South Africa in 1991 to that in 1999?
Ensure brevity in your answer.  0.86. What is the ratio of the Female students (as % of total students) in Ukraine in 1991 to that in 1999?
Provide a succinct answer. 1.27. What is the ratio of the Female students (as % of total students) in OECD members in 1991 to that in 2000?
Ensure brevity in your answer.  1.02. What is the ratio of the Female students (as % of total students) of Macao in 1991 to that in 2000?
Offer a terse response. 0.17. What is the ratio of the Female students (as % of total students) in South Africa in 1991 to that in 2000?
Offer a very short reply. 0.91. What is the ratio of the Female students (as % of total students) of Ukraine in 1991 to that in 2000?
Make the answer very short. 1.59. What is the ratio of the Female students (as % of total students) of OECD members in 1991 to that in 2001?
Provide a short and direct response. 1.03. What is the ratio of the Female students (as % of total students) in Macao in 1991 to that in 2001?
Your answer should be compact. 0.16. What is the ratio of the Female students (as % of total students) in South Africa in 1991 to that in 2001?
Your answer should be very brief. 0.91. What is the ratio of the Female students (as % of total students) of Ukraine in 1991 to that in 2001?
Offer a very short reply. 1.59. What is the ratio of the Female students (as % of total students) of OECD members in 1991 to that in 2002?
Provide a succinct answer. 1.03. What is the ratio of the Female students (as % of total students) in Macao in 1991 to that in 2002?
Offer a very short reply. 0.16. What is the ratio of the Female students (as % of total students) of South Africa in 1991 to that in 2002?
Give a very brief answer. 0.95. What is the ratio of the Female students (as % of total students) of Ukraine in 1991 to that in 2002?
Give a very brief answer. 1.58. What is the ratio of the Female students (as % of total students) of OECD members in 1991 to that in 2003?
Provide a succinct answer. 1.03. What is the ratio of the Female students (as % of total students) in Macao in 1991 to that in 2003?
Your answer should be compact. 0.16. What is the ratio of the Female students (as % of total students) in South Africa in 1991 to that in 2003?
Give a very brief answer. 0.95. What is the ratio of the Female students (as % of total students) in Ukraine in 1991 to that in 2003?
Provide a succinct answer. 1.56. What is the ratio of the Female students (as % of total students) in OECD members in 1991 to that in 2004?
Offer a terse response. 1.05. What is the ratio of the Female students (as % of total students) of Macao in 1991 to that in 2004?
Provide a short and direct response. 0.16. What is the ratio of the Female students (as % of total students) of South Africa in 1991 to that in 2004?
Make the answer very short. 0.95. What is the ratio of the Female students (as % of total students) in Ukraine in 1991 to that in 2004?
Provide a succinct answer. 1.56. What is the ratio of the Female students (as % of total students) in Macao in 1999 to that in 2000?
Give a very brief answer. 1.07. What is the ratio of the Female students (as % of total students) in South Africa in 1999 to that in 2000?
Your answer should be very brief. 1.05. What is the ratio of the Female students (as % of total students) in Ukraine in 1999 to that in 2000?
Make the answer very short. 1.25. What is the ratio of the Female students (as % of total students) of OECD members in 1999 to that in 2001?
Keep it short and to the point. 1. What is the ratio of the Female students (as % of total students) in Macao in 1999 to that in 2001?
Offer a very short reply. 1.05. What is the ratio of the Female students (as % of total students) in South Africa in 1999 to that in 2001?
Your response must be concise. 1.05. What is the ratio of the Female students (as % of total students) of Ukraine in 1999 to that in 2001?
Provide a succinct answer. 1.25. What is the ratio of the Female students (as % of total students) of Macao in 1999 to that in 2002?
Your answer should be very brief. 1.01. What is the ratio of the Female students (as % of total students) of South Africa in 1999 to that in 2002?
Offer a terse response. 1.1. What is the ratio of the Female students (as % of total students) of Ukraine in 1999 to that in 2002?
Your response must be concise. 1.24. What is the ratio of the Female students (as % of total students) of Macao in 1999 to that in 2003?
Offer a terse response. 1.01. What is the ratio of the Female students (as % of total students) in Ukraine in 1999 to that in 2003?
Ensure brevity in your answer.  1.22. What is the ratio of the Female students (as % of total students) in OECD members in 1999 to that in 2004?
Your answer should be compact. 1.01. What is the ratio of the Female students (as % of total students) of Ukraine in 1999 to that in 2004?
Offer a very short reply. 1.23. What is the ratio of the Female students (as % of total students) in OECD members in 2000 to that in 2001?
Your response must be concise. 1. What is the ratio of the Female students (as % of total students) in Macao in 2000 to that in 2001?
Offer a very short reply. 0.98. What is the ratio of the Female students (as % of total students) in OECD members in 2000 to that in 2002?
Provide a short and direct response. 1.01. What is the ratio of the Female students (as % of total students) in South Africa in 2000 to that in 2002?
Offer a very short reply. 1.05. What is the ratio of the Female students (as % of total students) of Ukraine in 2000 to that in 2002?
Offer a very short reply. 0.99. What is the ratio of the Female students (as % of total students) of Macao in 2000 to that in 2003?
Make the answer very short. 0.94. What is the ratio of the Female students (as % of total students) in Ukraine in 2000 to that in 2003?
Your answer should be compact. 0.98. What is the ratio of the Female students (as % of total students) in OECD members in 2000 to that in 2004?
Make the answer very short. 1.02. What is the ratio of the Female students (as % of total students) in Macao in 2000 to that in 2004?
Provide a succinct answer. 0.94. What is the ratio of the Female students (as % of total students) of Ukraine in 2000 to that in 2004?
Ensure brevity in your answer.  0.98. What is the ratio of the Female students (as % of total students) of Macao in 2001 to that in 2002?
Your answer should be compact. 0.97. What is the ratio of the Female students (as % of total students) in Macao in 2001 to that in 2003?
Give a very brief answer. 0.96. What is the ratio of the Female students (as % of total students) in Ukraine in 2001 to that in 2003?
Offer a terse response. 0.98. What is the ratio of the Female students (as % of total students) in OECD members in 2001 to that in 2004?
Offer a very short reply. 1.02. What is the ratio of the Female students (as % of total students) in Macao in 2001 to that in 2004?
Offer a very short reply. 0.96. What is the ratio of the Female students (as % of total students) in Ukraine in 2001 to that in 2004?
Keep it short and to the point. 0.98. What is the ratio of the Female students (as % of total students) of OECD members in 2002 to that in 2003?
Keep it short and to the point. 1. What is the ratio of the Female students (as % of total students) in Macao in 2002 to that in 2003?
Provide a short and direct response. 1. What is the ratio of the Female students (as % of total students) of South Africa in 2002 to that in 2003?
Offer a terse response. 1. What is the ratio of the Female students (as % of total students) in Ukraine in 2002 to that in 2003?
Make the answer very short. 0.99. What is the ratio of the Female students (as % of total students) of OECD members in 2002 to that in 2004?
Provide a succinct answer. 1.01. What is the ratio of the Female students (as % of total students) of Macao in 2002 to that in 2004?
Give a very brief answer. 1. What is the ratio of the Female students (as % of total students) in Ukraine in 2002 to that in 2004?
Provide a short and direct response. 0.99. What is the ratio of the Female students (as % of total students) in OECD members in 2003 to that in 2004?
Your answer should be very brief. 1.02. What is the ratio of the Female students (as % of total students) in South Africa in 2003 to that in 2004?
Ensure brevity in your answer.  1. What is the difference between the highest and the second highest Female students (as % of total students) of OECD members?
Keep it short and to the point. 0.02. What is the difference between the highest and the second highest Female students (as % of total students) of Macao?
Keep it short and to the point. 0.3. What is the difference between the highest and the second highest Female students (as % of total students) in South Africa?
Provide a short and direct response. 2. What is the difference between the highest and the second highest Female students (as % of total students) of Ukraine?
Ensure brevity in your answer.  0.06. What is the difference between the highest and the lowest Female students (as % of total students) in OECD members?
Offer a terse response. 2.03. What is the difference between the highest and the lowest Female students (as % of total students) in Macao?
Provide a short and direct response. 43.03. What is the difference between the highest and the lowest Female students (as % of total students) in South Africa?
Your answer should be compact. 5.94. What is the difference between the highest and the lowest Female students (as % of total students) in Ukraine?
Your response must be concise. 19.2. 